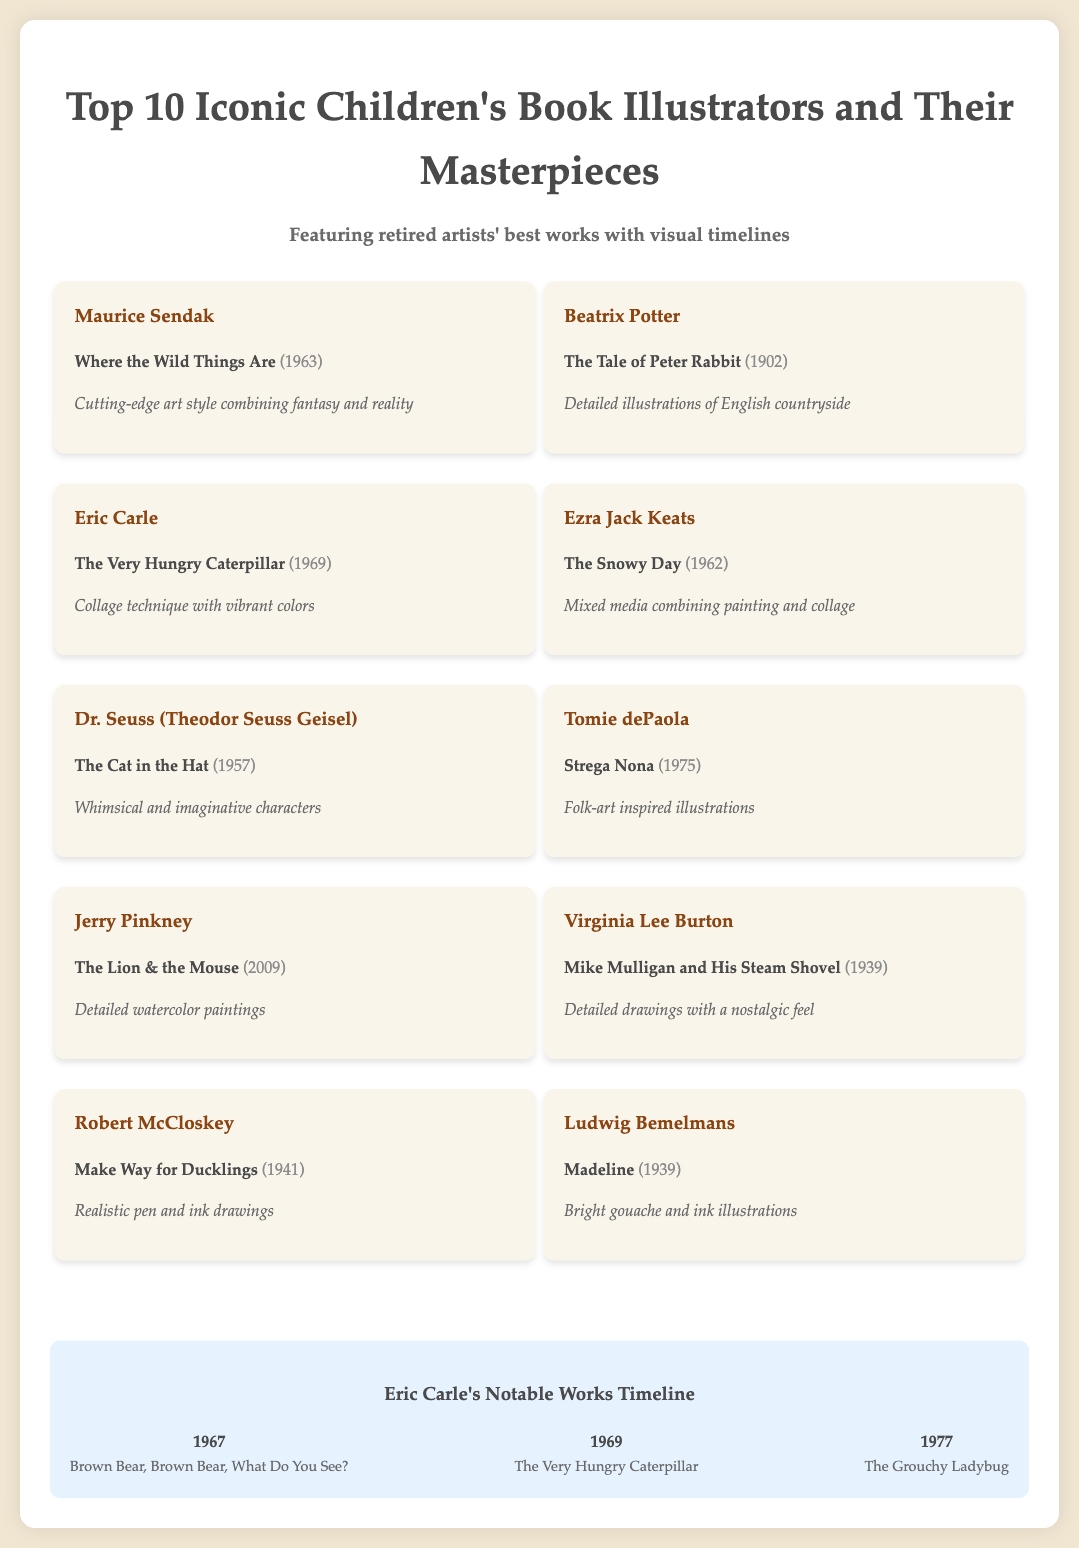What is the title of Eric Carle's famous book? The document lists "The Very Hungry Caterpillar" as Eric Carle's famous work.
Answer: The Very Hungry Caterpillar Who illustrated "Where the Wild Things Are"? The document states that Maurice Sendak is the illustrator of "Where the Wild Things Are".
Answer: Maurice Sendak In what year was "The Tale of Peter Rabbit" published? The document provides the publication year of "The Tale of Peter Rabbit" as 1902.
Answer: 1902 Which illustrator created the book “Madeline”? Ludwig Bemelmans is noted in the document as the creator of "Madeline".
Answer: Ludwig Bemelmans What art style is associated with Beatrix Potter's illustrations? The document describes Beatrix Potter's style as featuring detailed illustrations of the English countryside.
Answer: Detailed illustrations of English countryside List one notable work of Jerry Pinkney. The document mentions "The Lion & the Mouse" as a notable work by Jerry Pinkney.
Answer: The Lion & the Mouse Who published a work in 1941? The document indicates that Robert McCloskey published "Make Way for Ducklings" in 1941.
Answer: Robert McCloskey What type of illustrations did Tomie dePaola create for "Strega Nona"? The document notes that Tomie dePaola's illustrations are folk-art inspired.
Answer: Folk-art inspired illustrations What year was "The Cat in the Hat" released? The document lists the release year of "The Cat in the Hat" as 1957.
Answer: 1957 